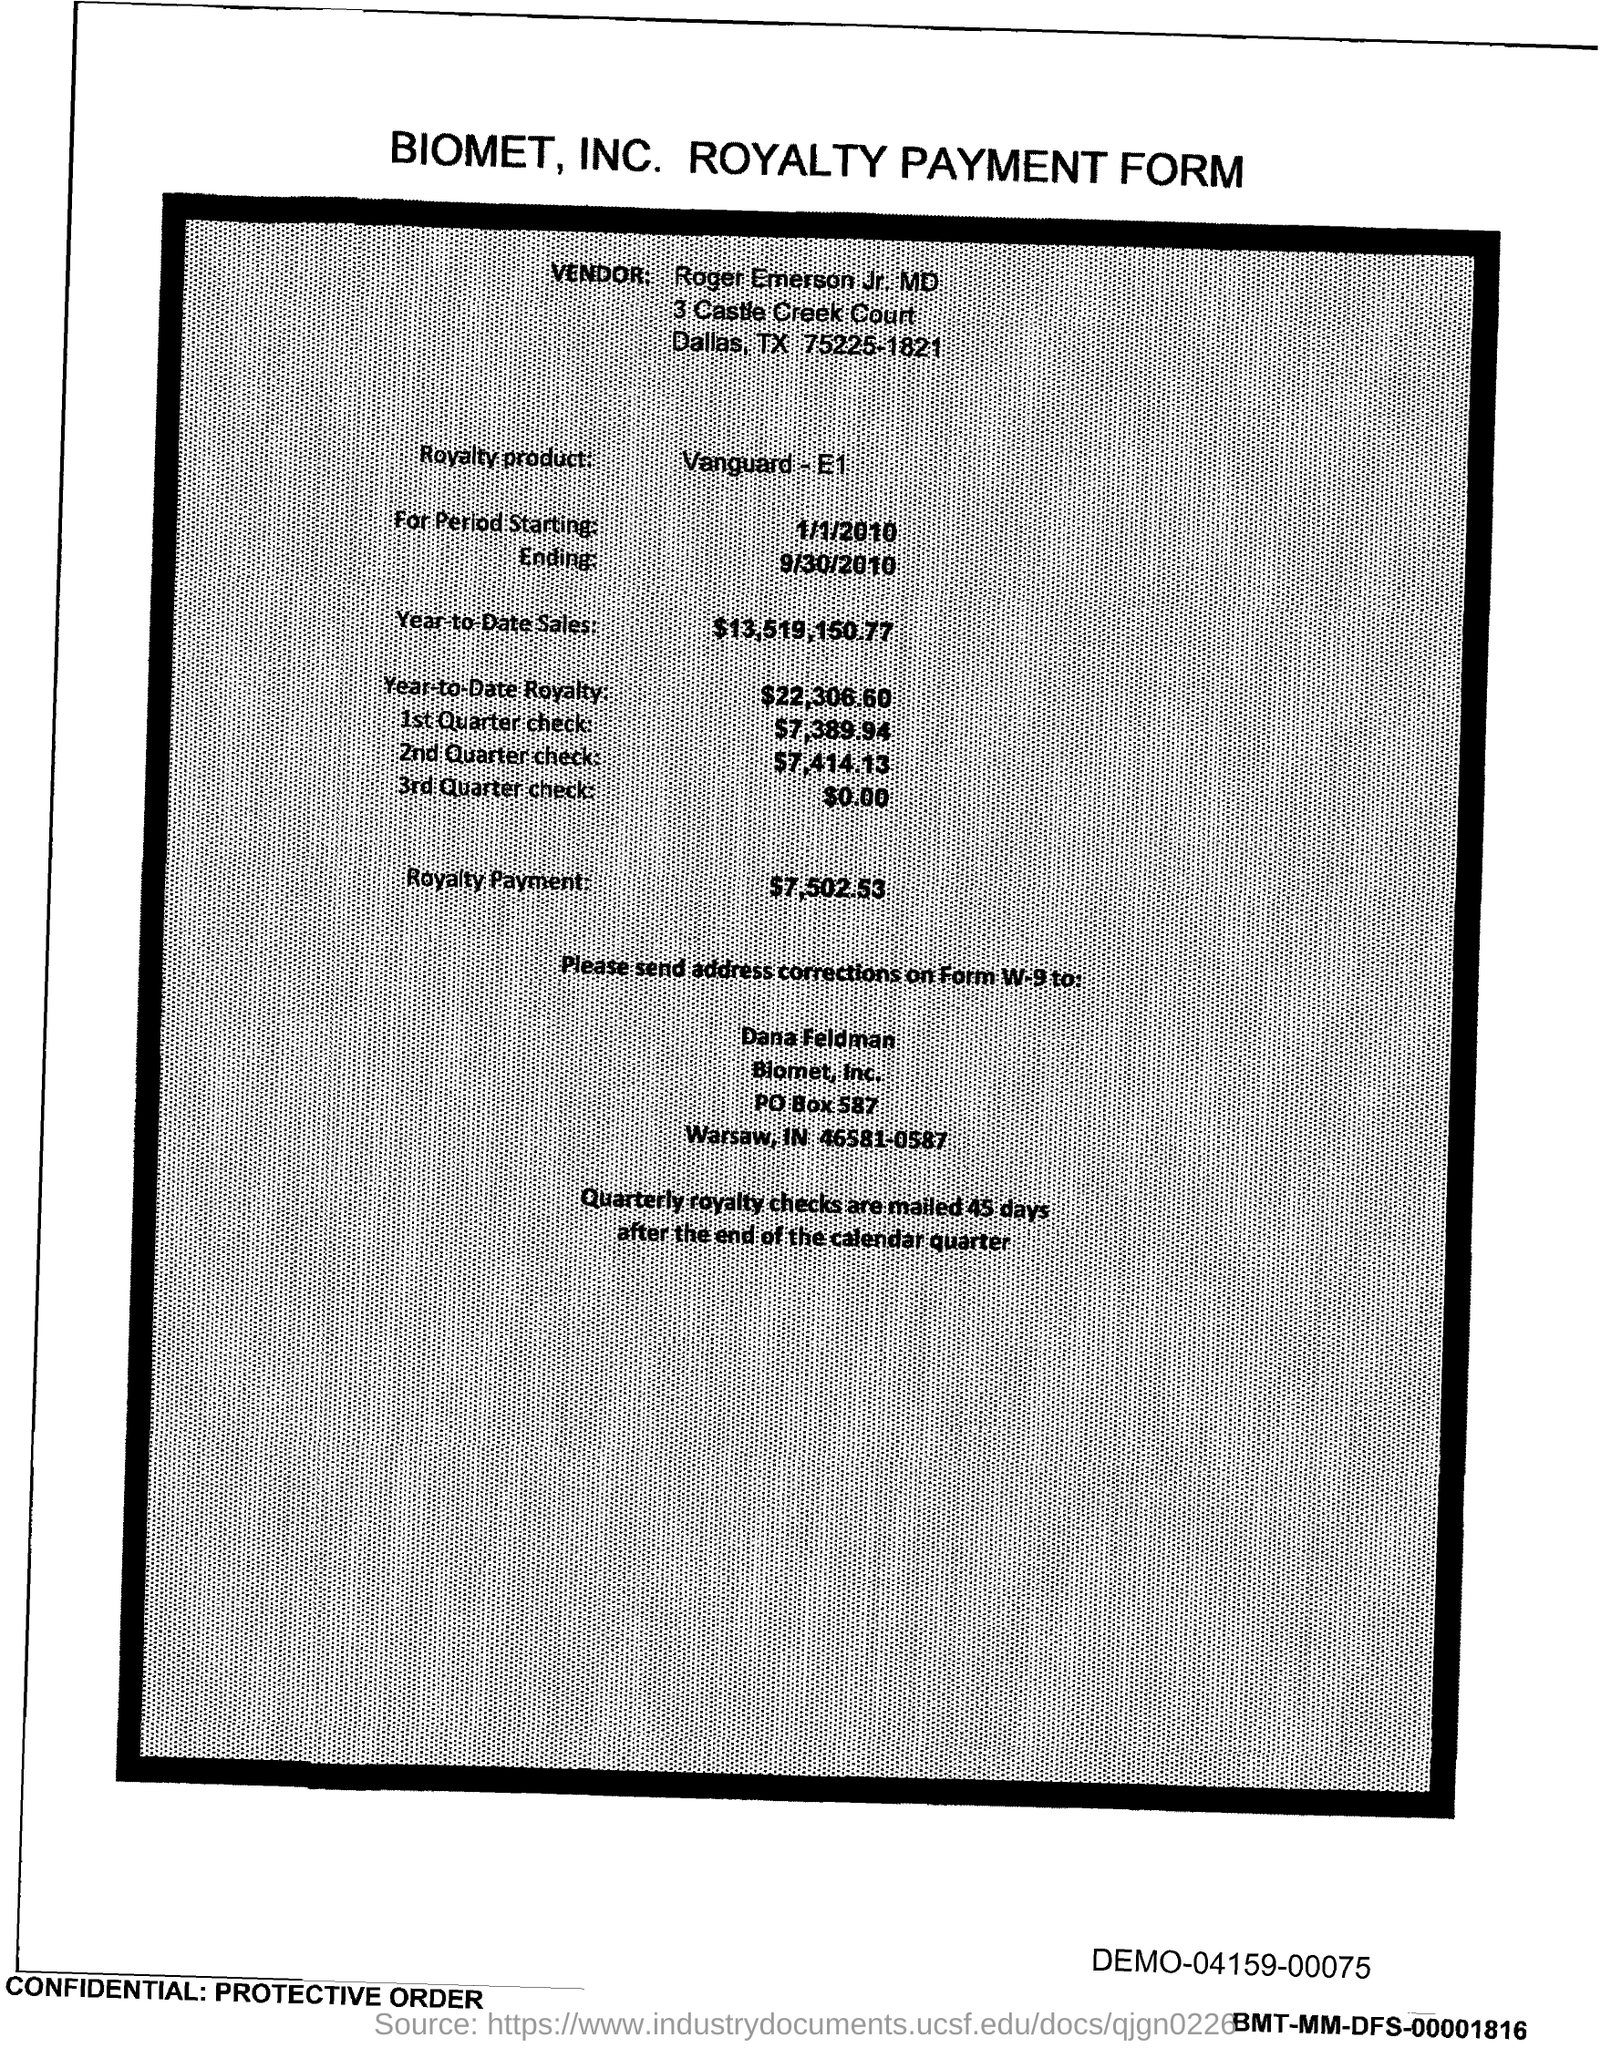What is the royalty product given in the form?
Your response must be concise. Vanguard - E1. What is the start date of the royalty period?
Provide a short and direct response. 1/1/2010. What is the Year-to-Date Sales of the royalty product?
Your response must be concise. $13,519,150.77. What is the Year-to-Date royalty of the product?
Your answer should be very brief. $22,306.60. What is the amount of 1st quarter check mentioned in the form?
Offer a very short reply. $7,389.94. What is the amount of 2nd Quarter check mentioned in the form?
Make the answer very short. $7,414.13. What is the amount of 3rd Quarter check given in the form?
Provide a short and direct response. $0.00. What is the royalty payment of the product mentioned in the form?
Your answer should be very brief. $7,502.53. 